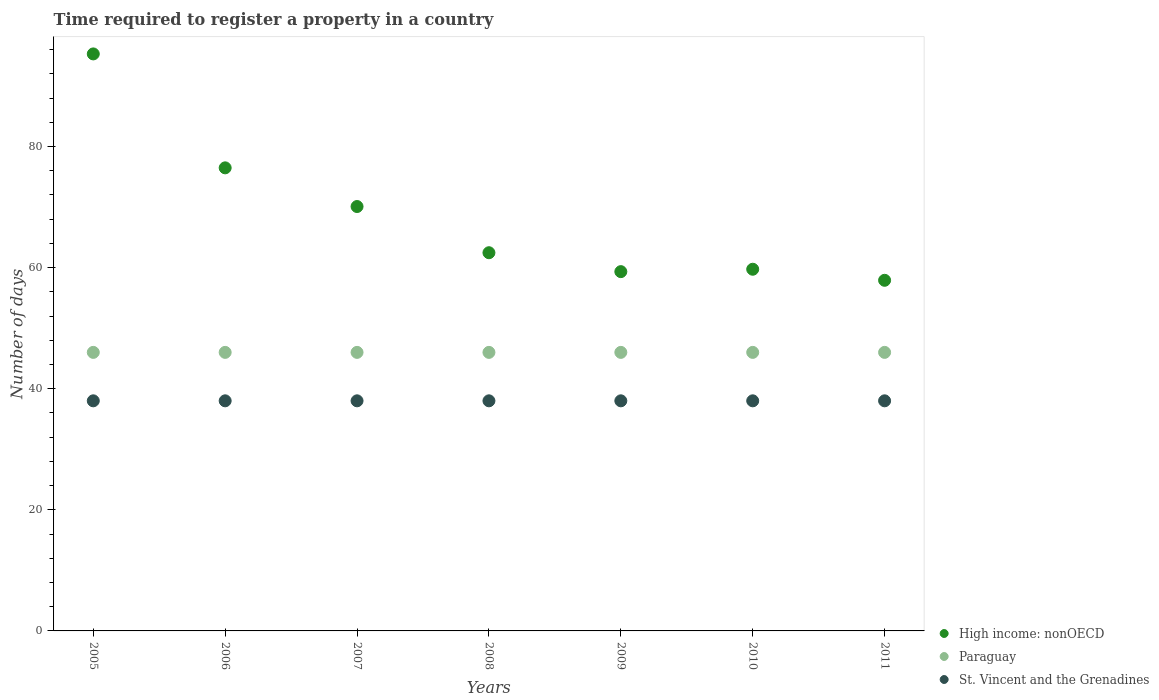Is the number of dotlines equal to the number of legend labels?
Keep it short and to the point. Yes. What is the number of days required to register a property in Paraguay in 2009?
Offer a very short reply. 46. Across all years, what is the maximum number of days required to register a property in St. Vincent and the Grenadines?
Make the answer very short. 38. Across all years, what is the minimum number of days required to register a property in Paraguay?
Offer a terse response. 46. In which year was the number of days required to register a property in St. Vincent and the Grenadines minimum?
Your answer should be very brief. 2005. What is the total number of days required to register a property in High income: nonOECD in the graph?
Keep it short and to the point. 481.28. What is the difference between the number of days required to register a property in High income: nonOECD in 2008 and that in 2010?
Provide a short and direct response. 2.73. What is the difference between the number of days required to register a property in High income: nonOECD in 2006 and the number of days required to register a property in St. Vincent and the Grenadines in 2005?
Give a very brief answer. 38.47. What is the average number of days required to register a property in St. Vincent and the Grenadines per year?
Provide a short and direct response. 38. In the year 2007, what is the difference between the number of days required to register a property in Paraguay and number of days required to register a property in High income: nonOECD?
Offer a terse response. -24.09. In how many years, is the number of days required to register a property in Paraguay greater than 16 days?
Make the answer very short. 7. What is the ratio of the number of days required to register a property in Paraguay in 2005 to that in 2009?
Your answer should be compact. 1. What is the difference between the highest and the second highest number of days required to register a property in St. Vincent and the Grenadines?
Your response must be concise. 0. Is the sum of the number of days required to register a property in High income: nonOECD in 2007 and 2009 greater than the maximum number of days required to register a property in St. Vincent and the Grenadines across all years?
Make the answer very short. Yes. Is it the case that in every year, the sum of the number of days required to register a property in St. Vincent and the Grenadines and number of days required to register a property in High income: nonOECD  is greater than the number of days required to register a property in Paraguay?
Provide a succinct answer. Yes. Does the number of days required to register a property in St. Vincent and the Grenadines monotonically increase over the years?
Offer a terse response. No. Is the number of days required to register a property in Paraguay strictly greater than the number of days required to register a property in High income: nonOECD over the years?
Offer a very short reply. No. How many years are there in the graph?
Offer a very short reply. 7. What is the difference between two consecutive major ticks on the Y-axis?
Provide a short and direct response. 20. Does the graph contain grids?
Keep it short and to the point. No. Where does the legend appear in the graph?
Provide a short and direct response. Bottom right. How many legend labels are there?
Your answer should be compact. 3. What is the title of the graph?
Offer a very short reply. Time required to register a property in a country. What is the label or title of the Y-axis?
Ensure brevity in your answer.  Number of days. What is the Number of days of High income: nonOECD in 2005?
Keep it short and to the point. 95.29. What is the Number of days in St. Vincent and the Grenadines in 2005?
Your response must be concise. 38. What is the Number of days of High income: nonOECD in 2006?
Ensure brevity in your answer.  76.47. What is the Number of days of High income: nonOECD in 2007?
Keep it short and to the point. 70.09. What is the Number of days in Paraguay in 2007?
Offer a terse response. 46. What is the Number of days of High income: nonOECD in 2008?
Offer a terse response. 62.46. What is the Number of days of Paraguay in 2008?
Your answer should be very brief. 46. What is the Number of days in St. Vincent and the Grenadines in 2008?
Keep it short and to the point. 38. What is the Number of days in High income: nonOECD in 2009?
Offer a very short reply. 59.33. What is the Number of days in St. Vincent and the Grenadines in 2009?
Keep it short and to the point. 38. What is the Number of days in High income: nonOECD in 2010?
Offer a terse response. 59.73. What is the Number of days in Paraguay in 2010?
Give a very brief answer. 46. What is the Number of days in St. Vincent and the Grenadines in 2010?
Ensure brevity in your answer.  38. What is the Number of days in High income: nonOECD in 2011?
Offer a terse response. 57.9. What is the Number of days of St. Vincent and the Grenadines in 2011?
Your answer should be very brief. 38. Across all years, what is the maximum Number of days of High income: nonOECD?
Offer a terse response. 95.29. Across all years, what is the maximum Number of days of Paraguay?
Your response must be concise. 46. Across all years, what is the maximum Number of days in St. Vincent and the Grenadines?
Keep it short and to the point. 38. Across all years, what is the minimum Number of days in High income: nonOECD?
Offer a terse response. 57.9. Across all years, what is the minimum Number of days in Paraguay?
Your answer should be very brief. 46. What is the total Number of days of High income: nonOECD in the graph?
Provide a short and direct response. 481.28. What is the total Number of days of Paraguay in the graph?
Your answer should be very brief. 322. What is the total Number of days in St. Vincent and the Grenadines in the graph?
Offer a terse response. 266. What is the difference between the Number of days in High income: nonOECD in 2005 and that in 2006?
Your answer should be compact. 18.81. What is the difference between the Number of days of Paraguay in 2005 and that in 2006?
Offer a terse response. 0. What is the difference between the Number of days of St. Vincent and the Grenadines in 2005 and that in 2006?
Give a very brief answer. 0. What is the difference between the Number of days of High income: nonOECD in 2005 and that in 2007?
Your answer should be compact. 25.2. What is the difference between the Number of days in St. Vincent and the Grenadines in 2005 and that in 2007?
Offer a terse response. 0. What is the difference between the Number of days in High income: nonOECD in 2005 and that in 2008?
Provide a short and direct response. 32.83. What is the difference between the Number of days in Paraguay in 2005 and that in 2008?
Offer a terse response. 0. What is the difference between the Number of days of High income: nonOECD in 2005 and that in 2009?
Ensure brevity in your answer.  35.96. What is the difference between the Number of days in St. Vincent and the Grenadines in 2005 and that in 2009?
Your answer should be compact. 0. What is the difference between the Number of days in High income: nonOECD in 2005 and that in 2010?
Provide a short and direct response. 35.56. What is the difference between the Number of days of St. Vincent and the Grenadines in 2005 and that in 2010?
Your answer should be compact. 0. What is the difference between the Number of days in High income: nonOECD in 2005 and that in 2011?
Offer a very short reply. 37.39. What is the difference between the Number of days of High income: nonOECD in 2006 and that in 2007?
Your response must be concise. 6.39. What is the difference between the Number of days of Paraguay in 2006 and that in 2007?
Provide a short and direct response. 0. What is the difference between the Number of days of High income: nonOECD in 2006 and that in 2008?
Give a very brief answer. 14.02. What is the difference between the Number of days in Paraguay in 2006 and that in 2008?
Ensure brevity in your answer.  0. What is the difference between the Number of days in High income: nonOECD in 2006 and that in 2009?
Provide a short and direct response. 17.14. What is the difference between the Number of days of High income: nonOECD in 2006 and that in 2010?
Your answer should be compact. 16.75. What is the difference between the Number of days of St. Vincent and the Grenadines in 2006 and that in 2010?
Your answer should be very brief. 0. What is the difference between the Number of days in High income: nonOECD in 2006 and that in 2011?
Keep it short and to the point. 18.57. What is the difference between the Number of days of High income: nonOECD in 2007 and that in 2008?
Give a very brief answer. 7.63. What is the difference between the Number of days of High income: nonOECD in 2007 and that in 2009?
Offer a very short reply. 10.75. What is the difference between the Number of days in High income: nonOECD in 2007 and that in 2010?
Provide a succinct answer. 10.36. What is the difference between the Number of days of St. Vincent and the Grenadines in 2007 and that in 2010?
Ensure brevity in your answer.  0. What is the difference between the Number of days in High income: nonOECD in 2007 and that in 2011?
Your answer should be very brief. 12.18. What is the difference between the Number of days in St. Vincent and the Grenadines in 2007 and that in 2011?
Give a very brief answer. 0. What is the difference between the Number of days in High income: nonOECD in 2008 and that in 2009?
Offer a very short reply. 3.12. What is the difference between the Number of days of High income: nonOECD in 2008 and that in 2010?
Your answer should be compact. 2.73. What is the difference between the Number of days in St. Vincent and the Grenadines in 2008 and that in 2010?
Give a very brief answer. 0. What is the difference between the Number of days in High income: nonOECD in 2008 and that in 2011?
Your answer should be compact. 4.55. What is the difference between the Number of days of Paraguay in 2008 and that in 2011?
Your answer should be very brief. 0. What is the difference between the Number of days of St. Vincent and the Grenadines in 2008 and that in 2011?
Offer a terse response. 0. What is the difference between the Number of days of High income: nonOECD in 2009 and that in 2010?
Offer a very short reply. -0.4. What is the difference between the Number of days of Paraguay in 2009 and that in 2010?
Keep it short and to the point. 0. What is the difference between the Number of days in High income: nonOECD in 2009 and that in 2011?
Your answer should be compact. 1.43. What is the difference between the Number of days of High income: nonOECD in 2010 and that in 2011?
Keep it short and to the point. 1.83. What is the difference between the Number of days of Paraguay in 2010 and that in 2011?
Make the answer very short. 0. What is the difference between the Number of days of High income: nonOECD in 2005 and the Number of days of Paraguay in 2006?
Offer a very short reply. 49.29. What is the difference between the Number of days in High income: nonOECD in 2005 and the Number of days in St. Vincent and the Grenadines in 2006?
Make the answer very short. 57.29. What is the difference between the Number of days in Paraguay in 2005 and the Number of days in St. Vincent and the Grenadines in 2006?
Provide a succinct answer. 8. What is the difference between the Number of days in High income: nonOECD in 2005 and the Number of days in Paraguay in 2007?
Give a very brief answer. 49.29. What is the difference between the Number of days in High income: nonOECD in 2005 and the Number of days in St. Vincent and the Grenadines in 2007?
Your answer should be very brief. 57.29. What is the difference between the Number of days of High income: nonOECD in 2005 and the Number of days of Paraguay in 2008?
Your response must be concise. 49.29. What is the difference between the Number of days of High income: nonOECD in 2005 and the Number of days of St. Vincent and the Grenadines in 2008?
Your answer should be very brief. 57.29. What is the difference between the Number of days in High income: nonOECD in 2005 and the Number of days in Paraguay in 2009?
Offer a terse response. 49.29. What is the difference between the Number of days of High income: nonOECD in 2005 and the Number of days of St. Vincent and the Grenadines in 2009?
Ensure brevity in your answer.  57.29. What is the difference between the Number of days of Paraguay in 2005 and the Number of days of St. Vincent and the Grenadines in 2009?
Make the answer very short. 8. What is the difference between the Number of days of High income: nonOECD in 2005 and the Number of days of Paraguay in 2010?
Offer a terse response. 49.29. What is the difference between the Number of days of High income: nonOECD in 2005 and the Number of days of St. Vincent and the Grenadines in 2010?
Your answer should be compact. 57.29. What is the difference between the Number of days in Paraguay in 2005 and the Number of days in St. Vincent and the Grenadines in 2010?
Provide a short and direct response. 8. What is the difference between the Number of days in High income: nonOECD in 2005 and the Number of days in Paraguay in 2011?
Your answer should be compact. 49.29. What is the difference between the Number of days in High income: nonOECD in 2005 and the Number of days in St. Vincent and the Grenadines in 2011?
Make the answer very short. 57.29. What is the difference between the Number of days in Paraguay in 2005 and the Number of days in St. Vincent and the Grenadines in 2011?
Give a very brief answer. 8. What is the difference between the Number of days in High income: nonOECD in 2006 and the Number of days in Paraguay in 2007?
Your answer should be very brief. 30.48. What is the difference between the Number of days in High income: nonOECD in 2006 and the Number of days in St. Vincent and the Grenadines in 2007?
Give a very brief answer. 38.48. What is the difference between the Number of days in High income: nonOECD in 2006 and the Number of days in Paraguay in 2008?
Provide a short and direct response. 30.48. What is the difference between the Number of days of High income: nonOECD in 2006 and the Number of days of St. Vincent and the Grenadines in 2008?
Your answer should be very brief. 38.48. What is the difference between the Number of days in Paraguay in 2006 and the Number of days in St. Vincent and the Grenadines in 2008?
Provide a short and direct response. 8. What is the difference between the Number of days in High income: nonOECD in 2006 and the Number of days in Paraguay in 2009?
Provide a short and direct response. 30.48. What is the difference between the Number of days of High income: nonOECD in 2006 and the Number of days of St. Vincent and the Grenadines in 2009?
Your answer should be compact. 38.48. What is the difference between the Number of days in High income: nonOECD in 2006 and the Number of days in Paraguay in 2010?
Give a very brief answer. 30.48. What is the difference between the Number of days of High income: nonOECD in 2006 and the Number of days of St. Vincent and the Grenadines in 2010?
Ensure brevity in your answer.  38.48. What is the difference between the Number of days of Paraguay in 2006 and the Number of days of St. Vincent and the Grenadines in 2010?
Keep it short and to the point. 8. What is the difference between the Number of days of High income: nonOECD in 2006 and the Number of days of Paraguay in 2011?
Ensure brevity in your answer.  30.48. What is the difference between the Number of days in High income: nonOECD in 2006 and the Number of days in St. Vincent and the Grenadines in 2011?
Ensure brevity in your answer.  38.48. What is the difference between the Number of days in Paraguay in 2006 and the Number of days in St. Vincent and the Grenadines in 2011?
Your response must be concise. 8. What is the difference between the Number of days in High income: nonOECD in 2007 and the Number of days in Paraguay in 2008?
Ensure brevity in your answer.  24.09. What is the difference between the Number of days of High income: nonOECD in 2007 and the Number of days of St. Vincent and the Grenadines in 2008?
Make the answer very short. 32.09. What is the difference between the Number of days of Paraguay in 2007 and the Number of days of St. Vincent and the Grenadines in 2008?
Provide a short and direct response. 8. What is the difference between the Number of days of High income: nonOECD in 2007 and the Number of days of Paraguay in 2009?
Provide a short and direct response. 24.09. What is the difference between the Number of days in High income: nonOECD in 2007 and the Number of days in St. Vincent and the Grenadines in 2009?
Provide a short and direct response. 32.09. What is the difference between the Number of days in High income: nonOECD in 2007 and the Number of days in Paraguay in 2010?
Provide a short and direct response. 24.09. What is the difference between the Number of days in High income: nonOECD in 2007 and the Number of days in St. Vincent and the Grenadines in 2010?
Ensure brevity in your answer.  32.09. What is the difference between the Number of days of Paraguay in 2007 and the Number of days of St. Vincent and the Grenadines in 2010?
Make the answer very short. 8. What is the difference between the Number of days of High income: nonOECD in 2007 and the Number of days of Paraguay in 2011?
Your answer should be compact. 24.09. What is the difference between the Number of days in High income: nonOECD in 2007 and the Number of days in St. Vincent and the Grenadines in 2011?
Make the answer very short. 32.09. What is the difference between the Number of days in High income: nonOECD in 2008 and the Number of days in Paraguay in 2009?
Provide a succinct answer. 16.46. What is the difference between the Number of days in High income: nonOECD in 2008 and the Number of days in St. Vincent and the Grenadines in 2009?
Your answer should be very brief. 24.46. What is the difference between the Number of days in Paraguay in 2008 and the Number of days in St. Vincent and the Grenadines in 2009?
Your answer should be compact. 8. What is the difference between the Number of days in High income: nonOECD in 2008 and the Number of days in Paraguay in 2010?
Ensure brevity in your answer.  16.46. What is the difference between the Number of days of High income: nonOECD in 2008 and the Number of days of St. Vincent and the Grenadines in 2010?
Give a very brief answer. 24.46. What is the difference between the Number of days in Paraguay in 2008 and the Number of days in St. Vincent and the Grenadines in 2010?
Ensure brevity in your answer.  8. What is the difference between the Number of days in High income: nonOECD in 2008 and the Number of days in Paraguay in 2011?
Keep it short and to the point. 16.46. What is the difference between the Number of days in High income: nonOECD in 2008 and the Number of days in St. Vincent and the Grenadines in 2011?
Make the answer very short. 24.46. What is the difference between the Number of days of Paraguay in 2008 and the Number of days of St. Vincent and the Grenadines in 2011?
Offer a terse response. 8. What is the difference between the Number of days in High income: nonOECD in 2009 and the Number of days in Paraguay in 2010?
Your answer should be compact. 13.33. What is the difference between the Number of days of High income: nonOECD in 2009 and the Number of days of St. Vincent and the Grenadines in 2010?
Ensure brevity in your answer.  21.33. What is the difference between the Number of days in Paraguay in 2009 and the Number of days in St. Vincent and the Grenadines in 2010?
Keep it short and to the point. 8. What is the difference between the Number of days in High income: nonOECD in 2009 and the Number of days in Paraguay in 2011?
Provide a succinct answer. 13.33. What is the difference between the Number of days of High income: nonOECD in 2009 and the Number of days of St. Vincent and the Grenadines in 2011?
Your response must be concise. 21.33. What is the difference between the Number of days of High income: nonOECD in 2010 and the Number of days of Paraguay in 2011?
Offer a very short reply. 13.73. What is the difference between the Number of days of High income: nonOECD in 2010 and the Number of days of St. Vincent and the Grenadines in 2011?
Your answer should be very brief. 21.73. What is the average Number of days of High income: nonOECD per year?
Make the answer very short. 68.75. What is the average Number of days in St. Vincent and the Grenadines per year?
Offer a terse response. 38. In the year 2005, what is the difference between the Number of days of High income: nonOECD and Number of days of Paraguay?
Provide a short and direct response. 49.29. In the year 2005, what is the difference between the Number of days in High income: nonOECD and Number of days in St. Vincent and the Grenadines?
Your answer should be compact. 57.29. In the year 2005, what is the difference between the Number of days of Paraguay and Number of days of St. Vincent and the Grenadines?
Your answer should be compact. 8. In the year 2006, what is the difference between the Number of days of High income: nonOECD and Number of days of Paraguay?
Your answer should be compact. 30.48. In the year 2006, what is the difference between the Number of days in High income: nonOECD and Number of days in St. Vincent and the Grenadines?
Your answer should be compact. 38.48. In the year 2006, what is the difference between the Number of days in Paraguay and Number of days in St. Vincent and the Grenadines?
Your response must be concise. 8. In the year 2007, what is the difference between the Number of days in High income: nonOECD and Number of days in Paraguay?
Make the answer very short. 24.09. In the year 2007, what is the difference between the Number of days in High income: nonOECD and Number of days in St. Vincent and the Grenadines?
Ensure brevity in your answer.  32.09. In the year 2008, what is the difference between the Number of days of High income: nonOECD and Number of days of Paraguay?
Keep it short and to the point. 16.46. In the year 2008, what is the difference between the Number of days in High income: nonOECD and Number of days in St. Vincent and the Grenadines?
Make the answer very short. 24.46. In the year 2009, what is the difference between the Number of days in High income: nonOECD and Number of days in Paraguay?
Give a very brief answer. 13.33. In the year 2009, what is the difference between the Number of days of High income: nonOECD and Number of days of St. Vincent and the Grenadines?
Offer a terse response. 21.33. In the year 2010, what is the difference between the Number of days in High income: nonOECD and Number of days in Paraguay?
Offer a terse response. 13.73. In the year 2010, what is the difference between the Number of days of High income: nonOECD and Number of days of St. Vincent and the Grenadines?
Offer a terse response. 21.73. In the year 2010, what is the difference between the Number of days of Paraguay and Number of days of St. Vincent and the Grenadines?
Make the answer very short. 8. In the year 2011, what is the difference between the Number of days in High income: nonOECD and Number of days in Paraguay?
Your answer should be very brief. 11.9. In the year 2011, what is the difference between the Number of days of High income: nonOECD and Number of days of St. Vincent and the Grenadines?
Ensure brevity in your answer.  19.9. What is the ratio of the Number of days of High income: nonOECD in 2005 to that in 2006?
Offer a very short reply. 1.25. What is the ratio of the Number of days of Paraguay in 2005 to that in 2006?
Your answer should be compact. 1. What is the ratio of the Number of days of St. Vincent and the Grenadines in 2005 to that in 2006?
Provide a short and direct response. 1. What is the ratio of the Number of days in High income: nonOECD in 2005 to that in 2007?
Provide a short and direct response. 1.36. What is the ratio of the Number of days in High income: nonOECD in 2005 to that in 2008?
Give a very brief answer. 1.53. What is the ratio of the Number of days of St. Vincent and the Grenadines in 2005 to that in 2008?
Offer a very short reply. 1. What is the ratio of the Number of days in High income: nonOECD in 2005 to that in 2009?
Offer a terse response. 1.61. What is the ratio of the Number of days of High income: nonOECD in 2005 to that in 2010?
Make the answer very short. 1.6. What is the ratio of the Number of days of Paraguay in 2005 to that in 2010?
Your response must be concise. 1. What is the ratio of the Number of days of High income: nonOECD in 2005 to that in 2011?
Your answer should be very brief. 1.65. What is the ratio of the Number of days in St. Vincent and the Grenadines in 2005 to that in 2011?
Offer a very short reply. 1. What is the ratio of the Number of days in High income: nonOECD in 2006 to that in 2007?
Offer a very short reply. 1.09. What is the ratio of the Number of days of High income: nonOECD in 2006 to that in 2008?
Your response must be concise. 1.22. What is the ratio of the Number of days in Paraguay in 2006 to that in 2008?
Offer a very short reply. 1. What is the ratio of the Number of days of St. Vincent and the Grenadines in 2006 to that in 2008?
Your answer should be very brief. 1. What is the ratio of the Number of days of High income: nonOECD in 2006 to that in 2009?
Offer a terse response. 1.29. What is the ratio of the Number of days of St. Vincent and the Grenadines in 2006 to that in 2009?
Provide a succinct answer. 1. What is the ratio of the Number of days of High income: nonOECD in 2006 to that in 2010?
Your answer should be compact. 1.28. What is the ratio of the Number of days in Paraguay in 2006 to that in 2010?
Your answer should be compact. 1. What is the ratio of the Number of days in High income: nonOECD in 2006 to that in 2011?
Your answer should be compact. 1.32. What is the ratio of the Number of days in Paraguay in 2006 to that in 2011?
Make the answer very short. 1. What is the ratio of the Number of days in High income: nonOECD in 2007 to that in 2008?
Make the answer very short. 1.12. What is the ratio of the Number of days of St. Vincent and the Grenadines in 2007 to that in 2008?
Provide a short and direct response. 1. What is the ratio of the Number of days of High income: nonOECD in 2007 to that in 2009?
Offer a terse response. 1.18. What is the ratio of the Number of days of High income: nonOECD in 2007 to that in 2010?
Provide a short and direct response. 1.17. What is the ratio of the Number of days of St. Vincent and the Grenadines in 2007 to that in 2010?
Provide a short and direct response. 1. What is the ratio of the Number of days of High income: nonOECD in 2007 to that in 2011?
Keep it short and to the point. 1.21. What is the ratio of the Number of days of Paraguay in 2007 to that in 2011?
Keep it short and to the point. 1. What is the ratio of the Number of days of High income: nonOECD in 2008 to that in 2009?
Offer a terse response. 1.05. What is the ratio of the Number of days of Paraguay in 2008 to that in 2009?
Provide a short and direct response. 1. What is the ratio of the Number of days of St. Vincent and the Grenadines in 2008 to that in 2009?
Give a very brief answer. 1. What is the ratio of the Number of days of High income: nonOECD in 2008 to that in 2010?
Give a very brief answer. 1.05. What is the ratio of the Number of days of High income: nonOECD in 2008 to that in 2011?
Ensure brevity in your answer.  1.08. What is the ratio of the Number of days in St. Vincent and the Grenadines in 2008 to that in 2011?
Your answer should be very brief. 1. What is the ratio of the Number of days in High income: nonOECD in 2009 to that in 2010?
Keep it short and to the point. 0.99. What is the ratio of the Number of days of High income: nonOECD in 2009 to that in 2011?
Give a very brief answer. 1.02. What is the ratio of the Number of days in Paraguay in 2009 to that in 2011?
Your response must be concise. 1. What is the ratio of the Number of days of High income: nonOECD in 2010 to that in 2011?
Your answer should be compact. 1.03. What is the ratio of the Number of days of Paraguay in 2010 to that in 2011?
Provide a succinct answer. 1. What is the difference between the highest and the second highest Number of days of High income: nonOECD?
Your answer should be very brief. 18.81. What is the difference between the highest and the lowest Number of days in High income: nonOECD?
Make the answer very short. 37.39. What is the difference between the highest and the lowest Number of days of St. Vincent and the Grenadines?
Provide a succinct answer. 0. 